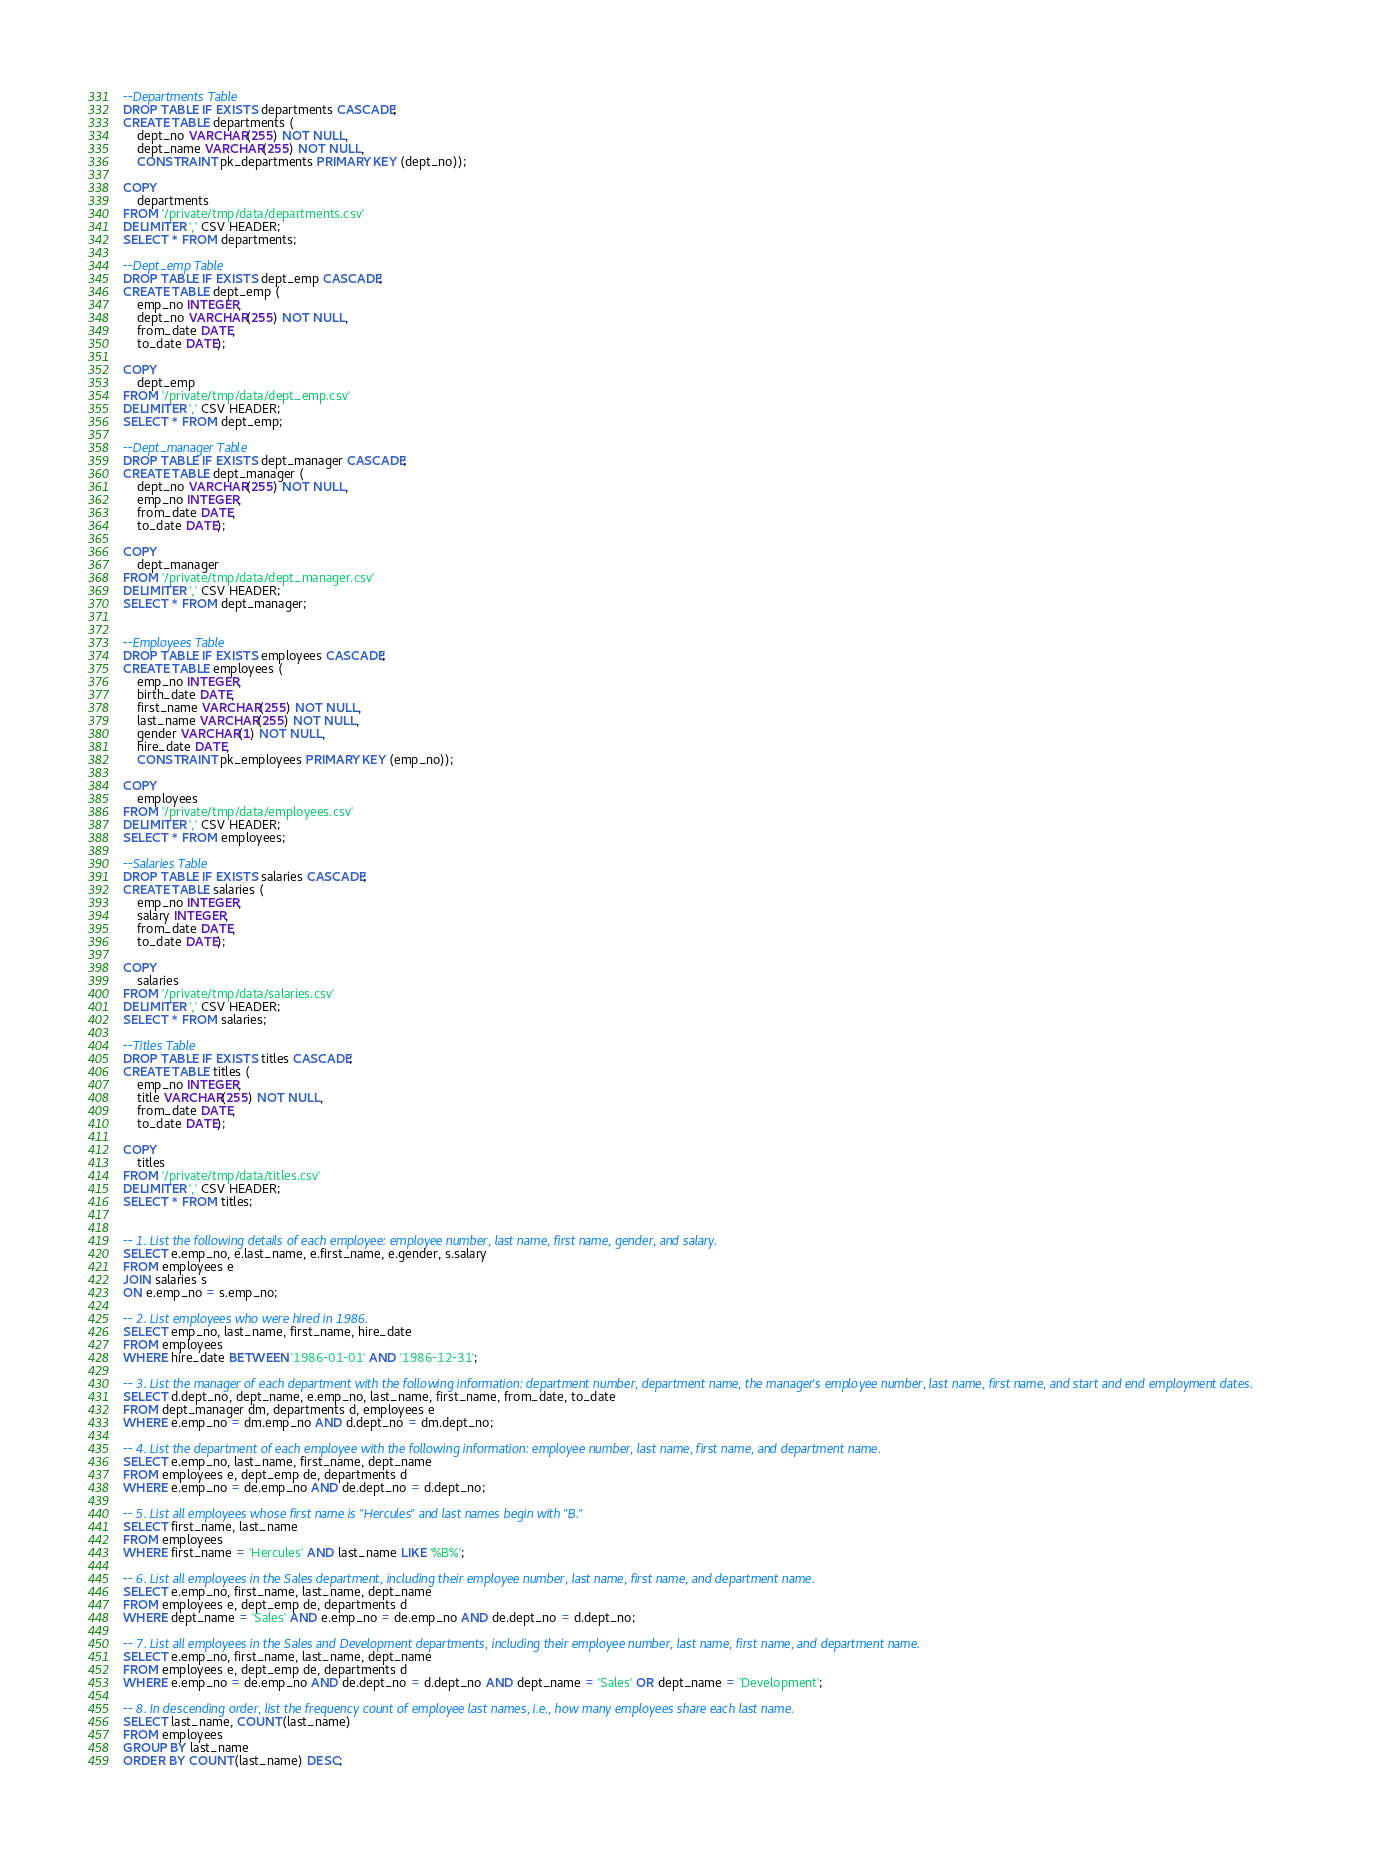<code> <loc_0><loc_0><loc_500><loc_500><_SQL_>--Departments Table
DROP TABLE IF EXISTS departments CASCADE;
CREATE TABLE departments (
	dept_no VARCHAR(255) NOT NULL,
	dept_name VARCHAR(255) NOT NULL,
	CONSTRAINT pk_departments PRIMARY KEY (dept_no));

COPY
	departments
FROM '/private/tmp/data/departments.csv'
DELIMITER ',' CSV HEADER;
SELECT * FROM departments;
	
--Dept_emp Table
DROP TABLE IF EXISTS dept_emp CASCADE;
CREATE TABLE dept_emp (
	emp_no INTEGER,
	dept_no VARCHAR(255) NOT NULL,
	from_date DATE,
	to_date DATE);

COPY
	dept_emp
FROM '/private/tmp/data/dept_emp.csv'
DELIMITER ',' CSV HEADER;
SELECT * FROM dept_emp;

--Dept_manager Table
DROP TABLE IF EXISTS dept_manager CASCADE;
CREATE TABLE dept_manager (
	dept_no VARCHAR(255) NOT NULL,
	emp_no INTEGER,
	from_date DATE,
	to_date DATE);

COPY
	dept_manager
FROM '/private/tmp/data/dept_manager.csv'
DELIMITER ',' CSV HEADER;
SELECT * FROM dept_manager;


--Employees Table
DROP TABLE IF EXISTS employees CASCADE;
CREATE TABLE employees (
	emp_no INTEGER,
	birth_date DATE,
	first_name VARCHAR(255) NOT NULL,
	last_name VARCHAR(255) NOT NULL,
	gender VARCHAR(1) NOT NULL,
	hire_date DATE,
	CONSTRAINT pk_employees PRIMARY KEY (emp_no));

COPY
	employees
FROM '/private/tmp/data/employees.csv'
DELIMITER ',' CSV HEADER;
SELECT * FROM employees;

--Salaries Table
DROP TABLE IF EXISTS salaries CASCADE;
CREATE TABLE salaries (
	emp_no INTEGER,
	salary INTEGER,
	from_date DATE,
	to_date DATE);

COPY
	salaries
FROM '/private/tmp/data/salaries.csv'
DELIMITER ',' CSV HEADER;
SELECT * FROM salaries;

--Titles Table
DROP TABLE IF EXISTS titles CASCADE;
CREATE TABLE titles (
	emp_no INTEGER,
	title VARCHAR(255) NOT NULL,
	from_date DATE,
	to_date DATE);

COPY
	titles
FROM '/private/tmp/data/titles.csv'
DELIMITER ',' CSV HEADER;
SELECT * FROM titles;


-- 1. List the following details of each employee: employee number, last name, first name, gender, and salary.
SELECT e.emp_no, e.last_name, e.first_name, e.gender, s.salary
FROM employees e
JOIN salaries s
ON e.emp_no = s.emp_no;
	
-- 2. List employees who were hired in 1986.
SELECT emp_no, last_name, first_name, hire_date
FROM employees
WHERE hire_date BETWEEN '1986-01-01' AND '1986-12-31';

-- 3. List the manager of each department with the following information: department number, department name, the manager's employee number, last name, first name, and start and end employment dates.
SELECT d.dept_no, dept_name, e.emp_no, last_name, first_name, from_date, to_date
FROM dept_manager dm, departments d, employees e
WHERE e.emp_no = dm.emp_no AND d.dept_no = dm.dept_no;

-- 4. List the department of each employee with the following information: employee number, last name, first name, and department name.
SELECT e.emp_no, last_name, first_name, dept_name
FROM employees e, dept_emp de, departments d
WHERE e.emp_no = de.emp_no AND de.dept_no = d.dept_no;

-- 5. List all employees whose first name is "Hercules" and last names begin with "B."
SELECT first_name, last_name
FROM employees
WHERE first_name = 'Hercules' AND last_name LIKE '%B%';

-- 6. List all employees in the Sales department, including their employee number, last name, first name, and department name.
SELECT e.emp_no, first_name, last_name, dept_name
FROM employees e, dept_emp de, departments d
WHERE dept_name = 'Sales' AND e.emp_no = de.emp_no AND de.dept_no = d.dept_no;

-- 7. List all employees in the Sales and Development departments, including their employee number, last name, first name, and department name.
SELECT e.emp_no, first_name, last_name, dept_name
FROM employees e, dept_emp de, departments d
WHERE e.emp_no = de.emp_no AND de.dept_no = d.dept_no AND dept_name = 'Sales' OR dept_name = 'Development';

-- 8. In descending order, list the frequency count of employee last names, i.e., how many employees share each last name.
SELECT last_name, COUNT(last_name)
FROM employees
GROUP BY last_name
ORDER BY COUNT(last_name) DESC;





</code> 